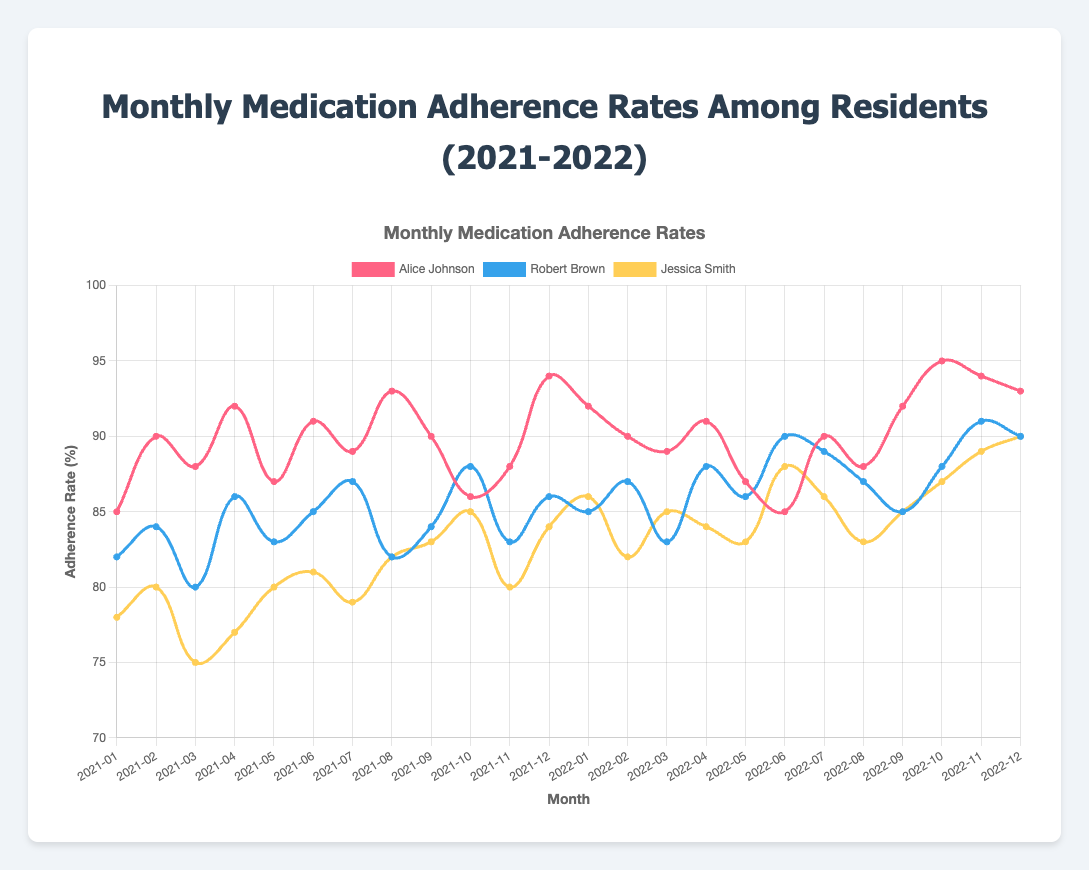What's the average adherence rate for Alice Johnson over the two years? First, sum up all the adherence rates for Alice Johnson: 85 + 90 + 88 + 92 + 87 + 91 + 89 + 93 + 90 + 86 + 88 + 94 + 92 + 90 + 89 + 91 + 87 + 85 + 90 + 88 + 92 + 95 + 94 + 93 = 2170. There are 24 months, so divide by 24 to get the average: 2170 / 24 = 90.42
Answer: 90.42 During which month and year did Robert Brown have the highest adherence rate? Look at Robert Brown's adherence rates across the months and find the highest value, 91, which occurs in November 2022.
Answer: November 2022 How does Jessica Smith's adherence rate in December 2022 compare to Alice Johnson's in the same month? Look at the adherence rates for December 2022 for both Jessica Smith (90) and Alice Johnson (93). Compare them: 90 is less than 93.
Answer: Jessica Smith's rate is less than Alice Johnson's Which resident showed the most significant improvement in medication adherence from January 2021 to December 2022? Calculate the differences between the adherence rates in January 2021 and December 2022 for each resident. Alice Johnson: 93 - 85 = 8, Robert Brown: 90 - 82 = 8, Jessica Smith: 90 - 78 = 12. Jessica Smith shows the most significant improvement.
Answer: Jessica Smith What's the total adherence rate difference for Robert Brown from the first month to the last month of each year? Calculate the differences for each year's first and last month: 2021: 86 - 82 = 4, 2022: 90 - 85 = 5. Sum the differences: 4 + 5 = 9.
Answer: 9 In which month and year did Alice Johnson have the lowest adherence rate, and what was it? Look through Alice Johnson's adherence rates and find the lowest value, 85, which occurs in January 2021 and June 2022.
Answer: January 2021 and June 2022, 85 Who had the highest adherence rate in October 2022, and what was it? Look at each resident's adherence rate in October 2022: Alice Johnson (95), Robert Brown (88), Jessica Smith (87). Alice Johnson has the highest adherence rate of 95.
Answer: Alice Johnson, 95 Compare the average adherence rate in 2021 to 2022 for Jessica Smith. Calculate the sum for 2021: (78 + 80 + 75 + 77 + 80 + 81 + 79 + 82 + 83 + 85 + 80 + 84 = 964) and the average: 964 / 12 = 80.33. For 2022: (86 + 82 + 85 + 84 + 83 + 88 + 86 + 83 + 85 + 87 + 89 + 90 = 1028) and the average: 1028 / 12 = 85.67. Compare the averages: 85.67 is higher.
Answer: 2022 is higher In which month did all three residents have their highest adherence rates in 2022? Check each residents' highest adherence rates for 2022: Alice Johnson (95 in October), Robert Brown (91 in November), Jessica Smith (90 in December). No single month overlaps for all.
Answer: No single month 